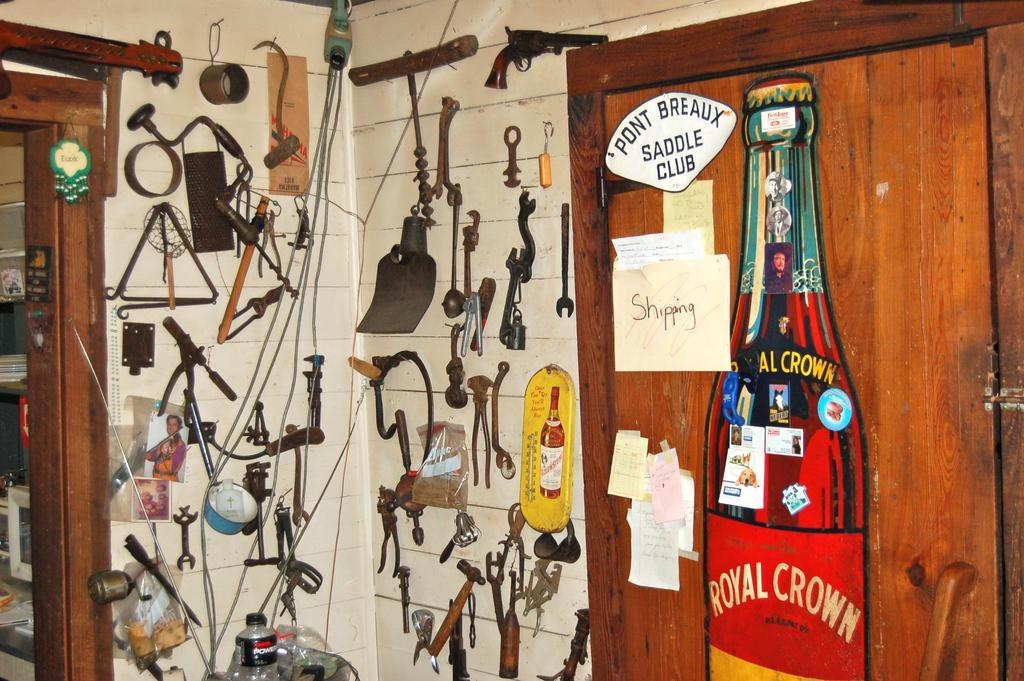Provide a one-sentence caption for the provided image. A room with a royal crown bottle poster hanging on a door and random knick knacks hanging on the walls. 